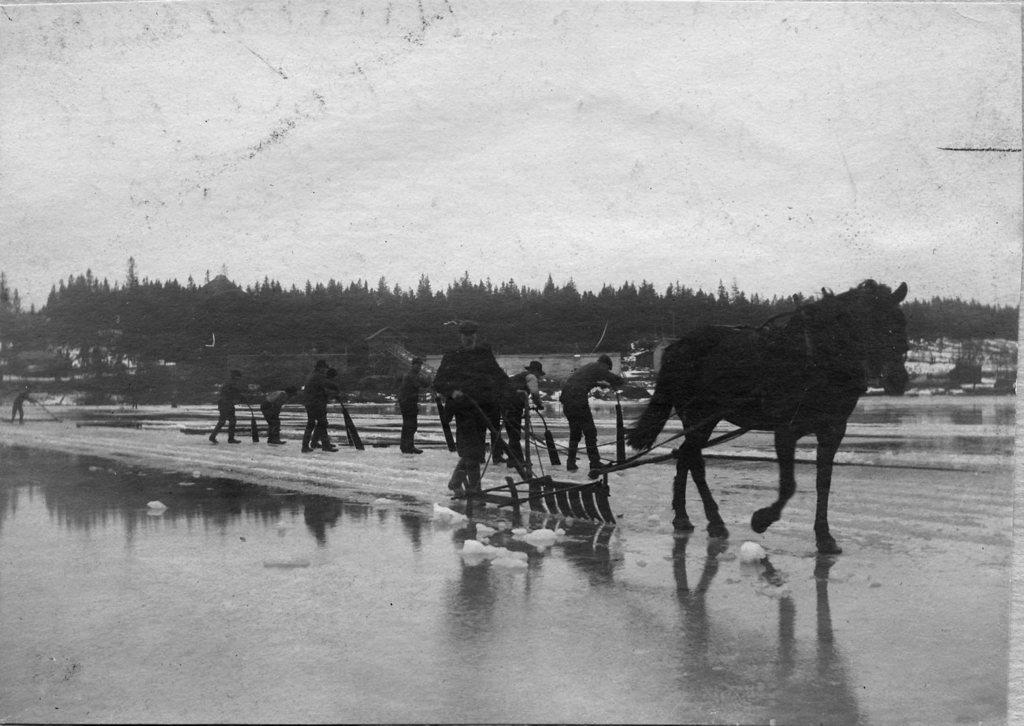What is located in the foreground of the picture? There are people, a horse, and a blade-like object in the foreground of the picture. What are the people doing in the picture? The people are trying to cut the ice. What can be seen in the background of the picture? There are trees and other objects in the background of the picture. How does the process of loss affect the scale of the objects in the image? The image does not depict any loss or changes in scale; it shows people, a horse, a blade-like object, and the background elements as they are. 